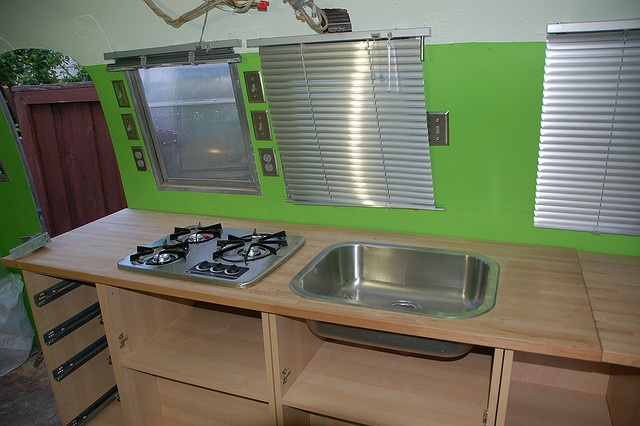Describe the objects in this image and their specific colors. I can see oven in gray and darkgray tones, sink in gray and black tones, and oven in gray and black tones in this image. 